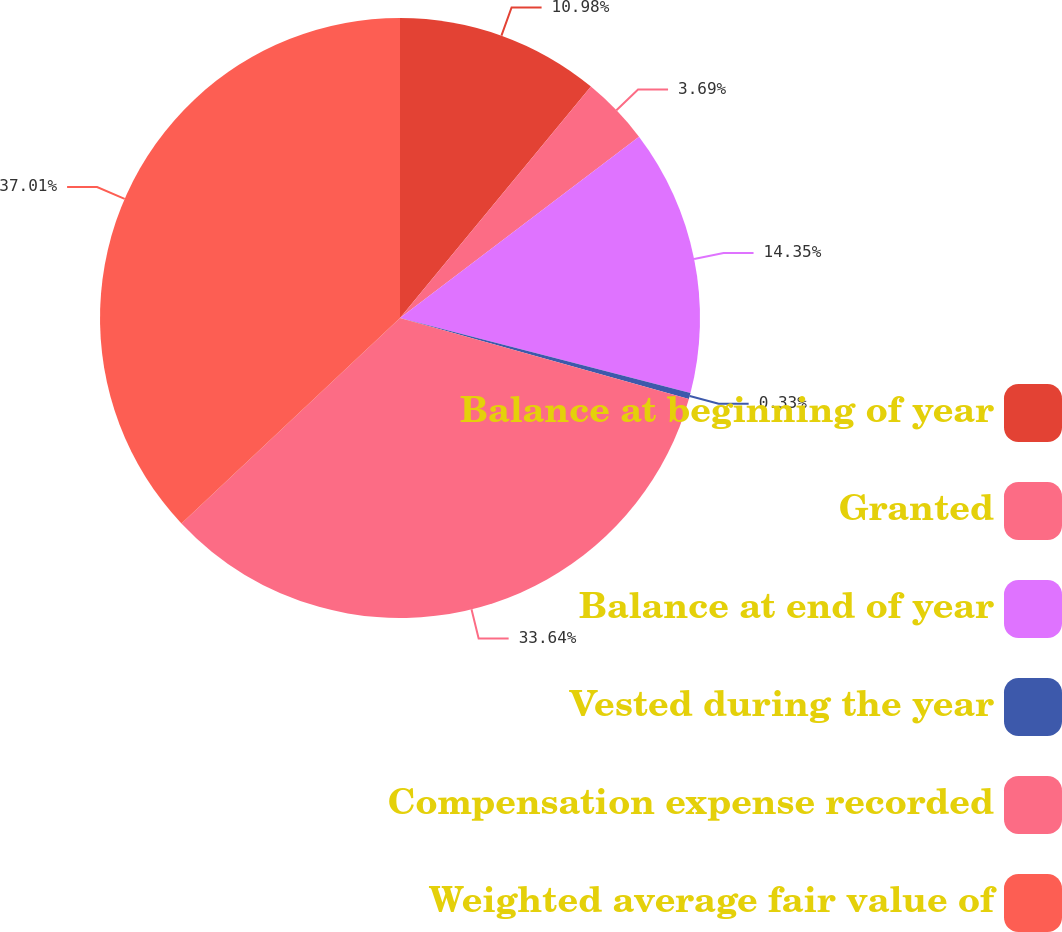Convert chart to OTSL. <chart><loc_0><loc_0><loc_500><loc_500><pie_chart><fcel>Balance at beginning of year<fcel>Granted<fcel>Balance at end of year<fcel>Vested during the year<fcel>Compensation expense recorded<fcel>Weighted average fair value of<nl><fcel>10.98%<fcel>3.69%<fcel>14.35%<fcel>0.33%<fcel>33.64%<fcel>37.01%<nl></chart> 